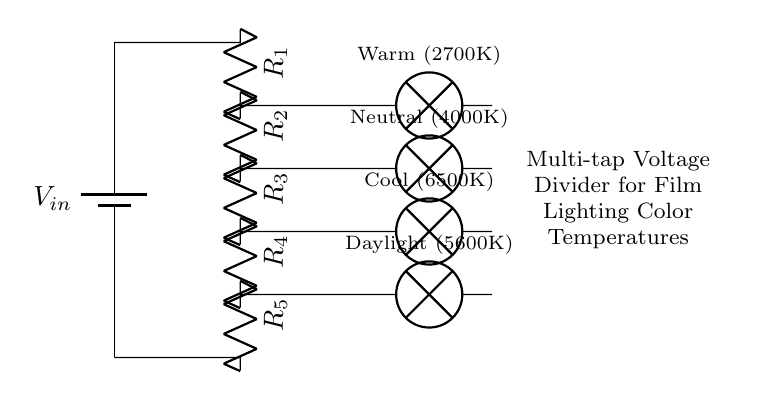What is the input voltage in this circuit? The circuit shows a battery labeled as \( V_{in} \) at the top, indicating it provides the input voltage to the circuit. The value is not specified, but it is a key component for operation.
Answer: V_in How many resistors are in this voltage divider? The circuit diagram includes five resistors connected in series, as labeled \( R_1 \) through \( R_5 \) vertically. The total number of resistors can be counted directly from the diagram.
Answer: 5 What is the purpose of the resistors in this circuit? The resistors in a voltage divider serve to divide the input voltage into smaller output voltages, which are used to power different types of lamps simulating various color temperatures.
Answer: Divide voltage What type of lamps are connected to this voltage divider? The circuit shows four types of lamps labeled for different color temperatures: Warm (2700K), Neutral (4000K), Cool (6500K), and Daylight (5600K), indicating the specific light characteristics they are designed to emit.
Answer: Warm, Neutral, Cool, Daylight What color temperature is associated with \( R_4 \)? Reviewing the circuit, \( R_4 \) is linked to the Daylight lamp, which is labeled as emitting a 5600K color temperature. This indicates the specific warmth or coolness of light produced.
Answer: 5600K Which lamp corresponds to the highest color temperature? Among the lamps indicated, the Cool lamp is associated with 6500K, which is the highest value in the diagram, and represents a very cool light output ideal for certain film lighting scenarios.
Answer: 6500K What happens if one resistor is removed from this circuit? If one resistor is removed, the voltage divider's output voltages will change because the ratio of the remaining resistors will be altered, causing different color temperatures to be emitted from the lamps improperly.
Answer: Voltage changes 